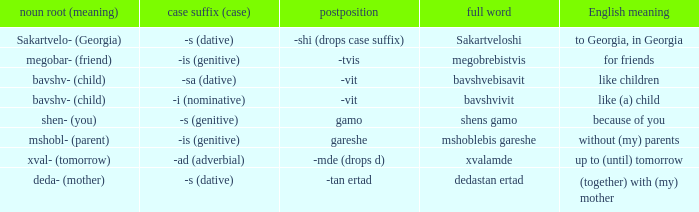What is English Meaning, when Case Suffix (Case) is "-sa (dative)"? Like children. 